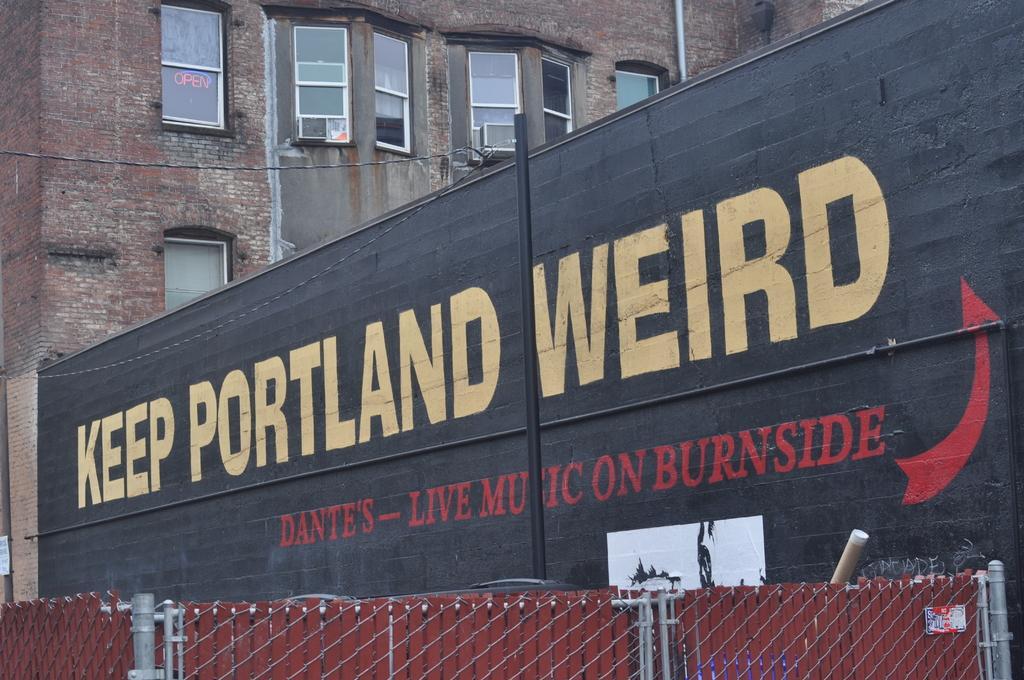Can you describe this image briefly? In this image there is a board on the wall. There is text on the board. Behind the board there is a building. There are glass windows on the walls of the building. In front of the board there is a pole. At the bottom there is a fencing. 